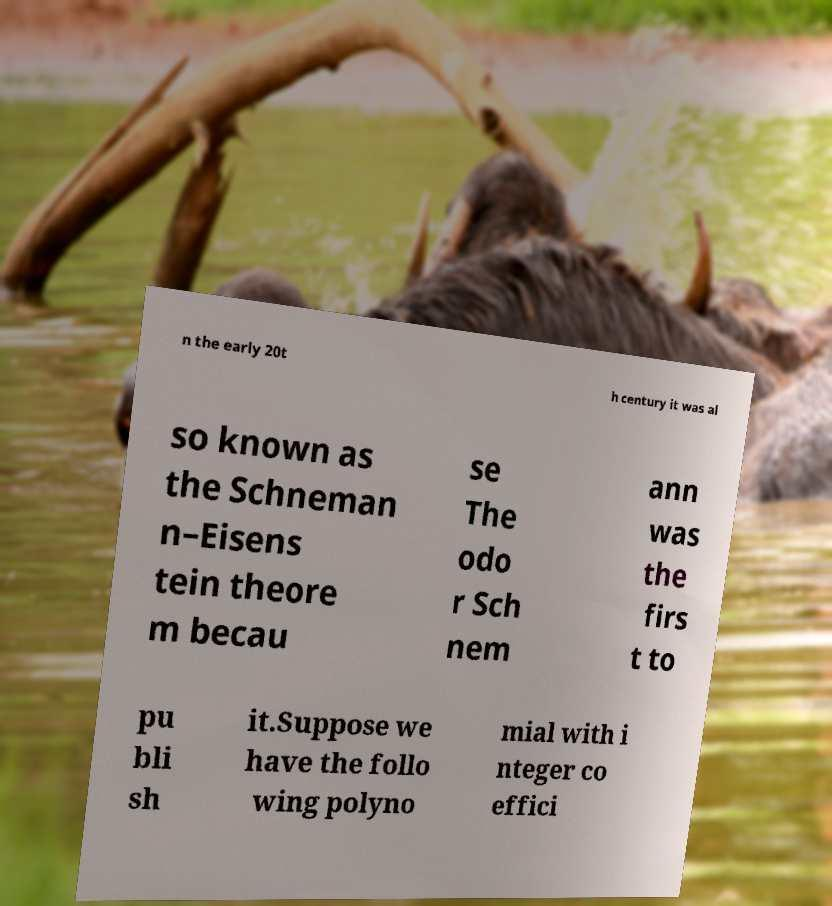Could you assist in decoding the text presented in this image and type it out clearly? n the early 20t h century it was al so known as the Schneman n–Eisens tein theore m becau se The odo r Sch nem ann was the firs t to pu bli sh it.Suppose we have the follo wing polyno mial with i nteger co effici 